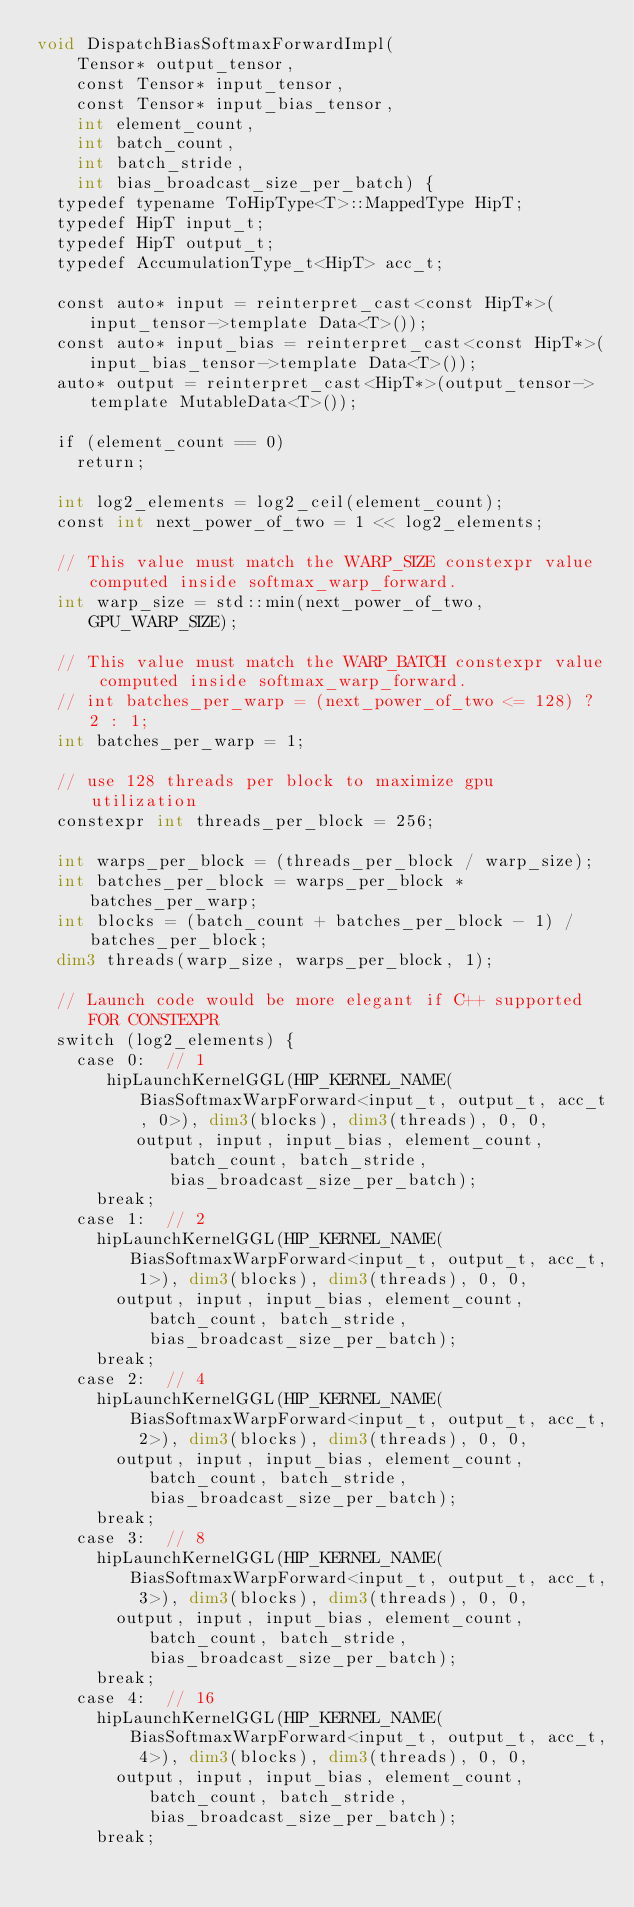<code> <loc_0><loc_0><loc_500><loc_500><_Cuda_>void DispatchBiasSoftmaxForwardImpl(
    Tensor* output_tensor,
    const Tensor* input_tensor,
    const Tensor* input_bias_tensor,
    int element_count,
    int batch_count,
    int batch_stride,
    int bias_broadcast_size_per_batch) {
  typedef typename ToHipType<T>::MappedType HipT;
  typedef HipT input_t;
  typedef HipT output_t;
  typedef AccumulationType_t<HipT> acc_t;

  const auto* input = reinterpret_cast<const HipT*>(input_tensor->template Data<T>());
  const auto* input_bias = reinterpret_cast<const HipT*>(input_bias_tensor->template Data<T>());
  auto* output = reinterpret_cast<HipT*>(output_tensor->template MutableData<T>());

  if (element_count == 0)
    return;

  int log2_elements = log2_ceil(element_count);
  const int next_power_of_two = 1 << log2_elements;

  // This value must match the WARP_SIZE constexpr value computed inside softmax_warp_forward.
  int warp_size = std::min(next_power_of_two, GPU_WARP_SIZE);

  // This value must match the WARP_BATCH constexpr value computed inside softmax_warp_forward.
  // int batches_per_warp = (next_power_of_two <= 128) ? 2 : 1;
  int batches_per_warp = 1;

  // use 128 threads per block to maximize gpu utilization
  constexpr int threads_per_block = 256;

  int warps_per_block = (threads_per_block / warp_size);
  int batches_per_block = warps_per_block * batches_per_warp;
  int blocks = (batch_count + batches_per_block - 1) / batches_per_block;
  dim3 threads(warp_size, warps_per_block, 1);

  // Launch code would be more elegant if C++ supported FOR CONSTEXPR
  switch (log2_elements) {
    case 0:  // 1
       hipLaunchKernelGGL(HIP_KERNEL_NAME(BiasSoftmaxWarpForward<input_t, output_t, acc_t, 0>), dim3(blocks), dim3(threads), 0, 0,
          output, input, input_bias, element_count, batch_count, batch_stride, bias_broadcast_size_per_batch);
      break;
    case 1:  // 2
      hipLaunchKernelGGL(HIP_KERNEL_NAME(BiasSoftmaxWarpForward<input_t, output_t, acc_t, 1>), dim3(blocks), dim3(threads), 0, 0,
        output, input, input_bias, element_count, batch_count, batch_stride, bias_broadcast_size_per_batch);
      break;
    case 2:  // 4
      hipLaunchKernelGGL(HIP_KERNEL_NAME(BiasSoftmaxWarpForward<input_t, output_t, acc_t, 2>), dim3(blocks), dim3(threads), 0, 0,
        output, input, input_bias, element_count, batch_count, batch_stride, bias_broadcast_size_per_batch);
      break;
    case 3:  // 8
      hipLaunchKernelGGL(HIP_KERNEL_NAME(BiasSoftmaxWarpForward<input_t, output_t, acc_t, 3>), dim3(blocks), dim3(threads), 0, 0,
        output, input, input_bias, element_count, batch_count, batch_stride, bias_broadcast_size_per_batch);
      break;
    case 4:  // 16
      hipLaunchKernelGGL(HIP_KERNEL_NAME(BiasSoftmaxWarpForward<input_t, output_t, acc_t, 4>), dim3(blocks), dim3(threads), 0, 0,
        output, input, input_bias, element_count, batch_count, batch_stride, bias_broadcast_size_per_batch);
      break;</code> 